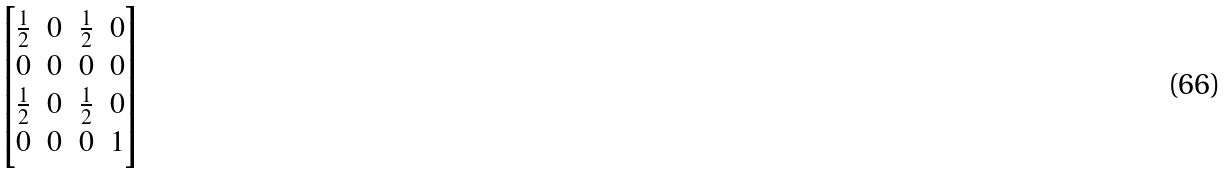Convert formula to latex. <formula><loc_0><loc_0><loc_500><loc_500>\begin{bmatrix} \frac { 1 } { 2 } & 0 & \frac { 1 } { 2 } & 0 \\ 0 & 0 & 0 & 0 \\ \frac { 1 } { 2 } & 0 & \frac { 1 } { 2 } & 0 \\ 0 & 0 & 0 & 1 \end{bmatrix}</formula> 